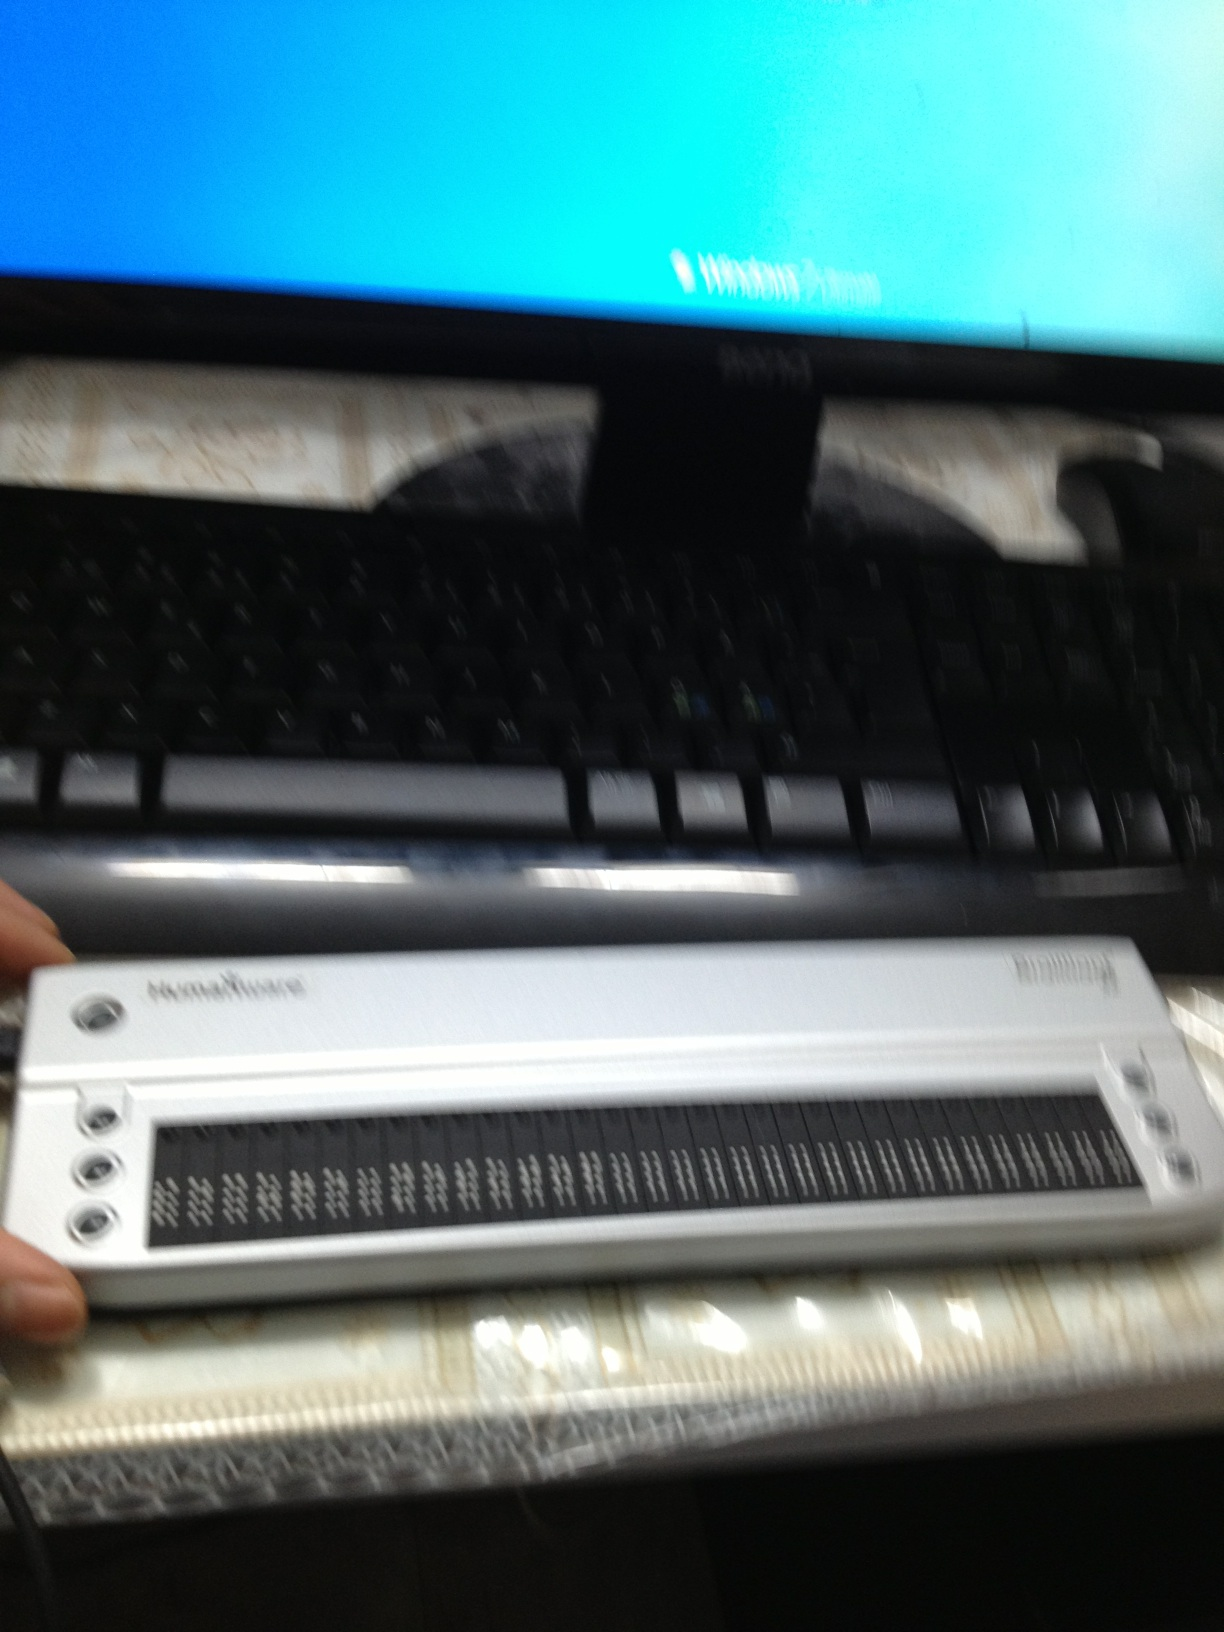Describe the setting shown in the image. The image shows a setup consisting of a computer monitor displaying a blurred Windows login screen and a keyboard. In front of the keyboard, there's a refreshable braille display that assists visually impaired individuals by converting digital text into braille. The workspace appears to be designed to accommodate accessibility needs. 